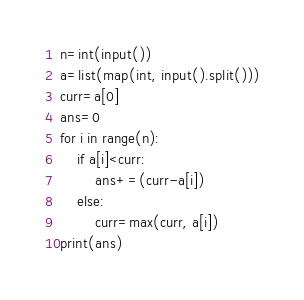<code> <loc_0><loc_0><loc_500><loc_500><_Python_>n=int(input())
a=list(map(int, input().split()))
curr=a[0]
ans=0
for i in range(n):
    if a[i]<curr:
        ans+=(curr-a[i])
    else:
        curr=max(curr, a[i])
print(ans)</code> 